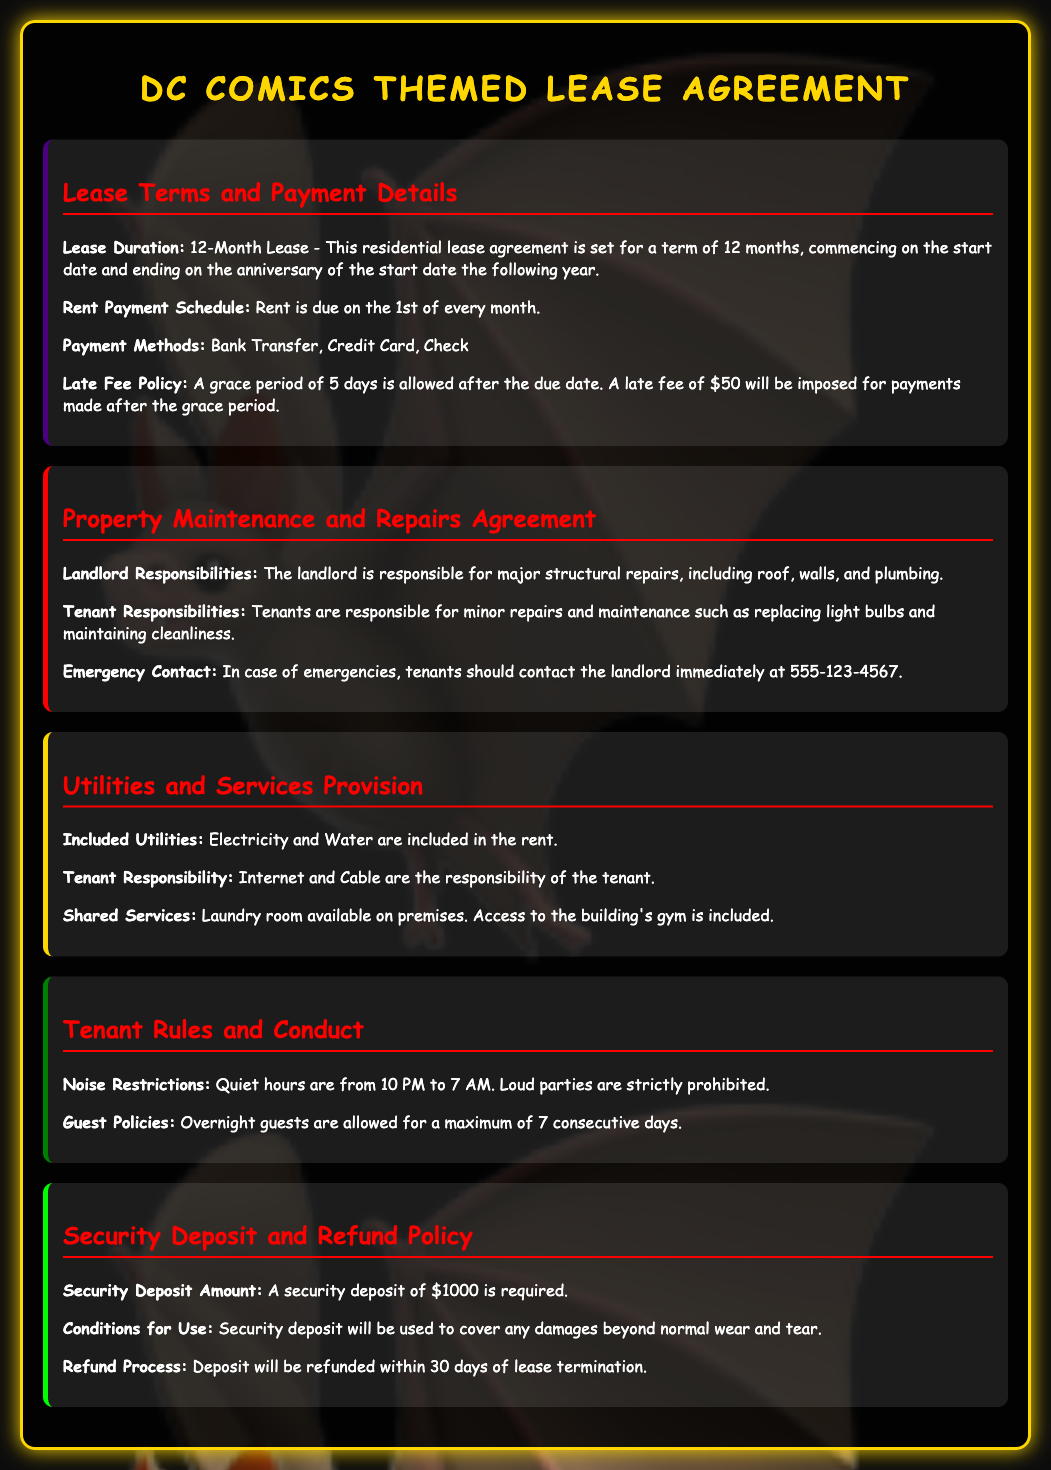what is the lease duration? The lease duration is specified as a term of 12 months, commencing on the start date and ending on the anniversary of the start date the following year.
Answer: 12 months when is rent due? The rent payment schedule indicates that rent is due on the 1st of every month.
Answer: 1st of every month what is the late fee amount? The late fee policy states a late fee will be imposed for payments made after the grace period. This late fee is $50.
Answer: $50 how long is the grace period for late payments? The late fee policy includes a grace period of 5 days after the due date for late payments.
Answer: 5 days how much is the security deposit? The security deposit amount required is specified in the document. It is $1000.
Answer: $1000 who is responsible for major repairs? The property maintenance section mentions that the landlord is responsible for major structural repairs, including roof, walls, and plumbing.
Answer: landlord what utilities are included in the rent? The utilities included in the lease are stated to be Electricity and Water.
Answer: Electricity and Water what is the maximum duration for overnight guests? The tenant conduct section specifies that overnight guests can stay for a maximum of 7 consecutive days.
Answer: 7 consecutive days what is the refund process time for the security deposit? The refund process outlined for the security deposit indicates it will be refunded within 30 days of lease termination.
Answer: 30 days 